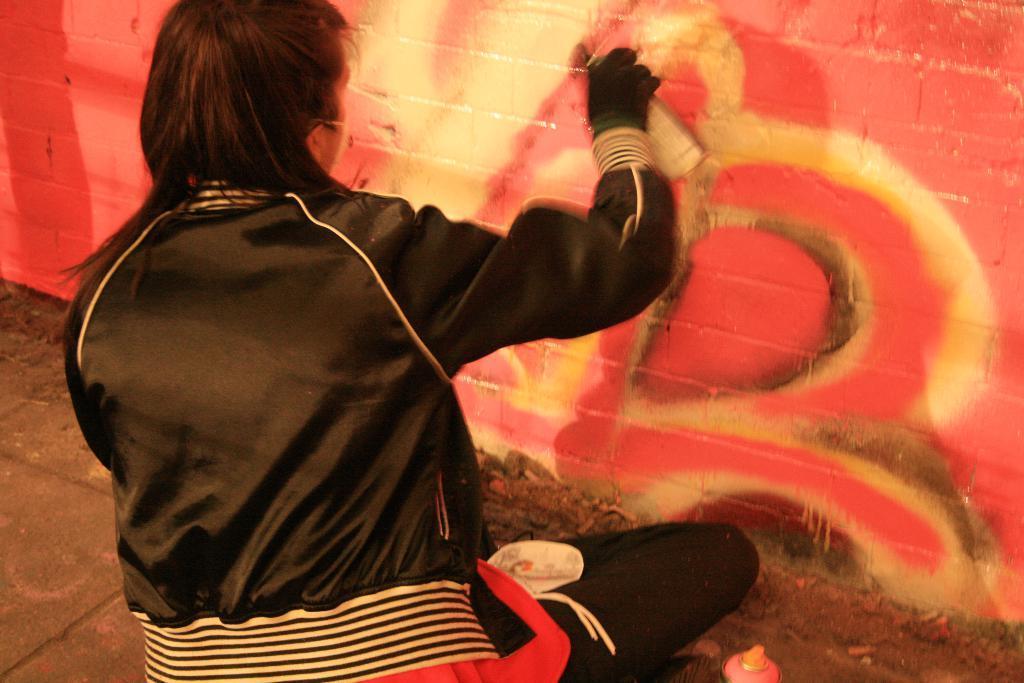Describe this image in one or two sentences. In the picture I can see a person wearing black jacket and gloves is sitting on the floor and holding an object in their hands. In the background, we can see the wall on which we can see the red color paint. 